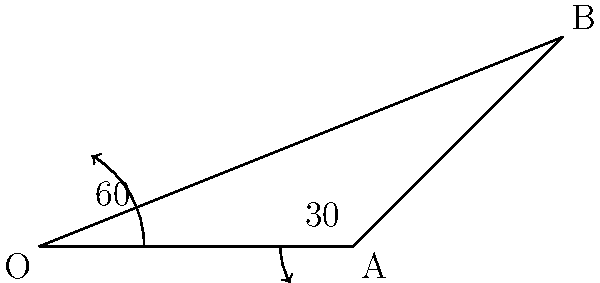In a karate punch, your arm starts at point O and moves to point A (elbow position), then to point B (fist extended). If the angle between OA and AB is 30°, and the angle between OA and the horizontal is 60°, what is the angle between AB and the horizontal? Let's solve this step-by-step:

1. We know that a straight line forms a 180° angle.
2. The arm starts horizontal (0°), then moves up 60°.
3. So, the angle between OA and the horizontal is 60°.
4. The angle between OA and AB is given as 30°.
5. To find the angle between AB and the horizontal, we need to add these angles:
   $60° + 30° = 90°$
6. Therefore, the angle between AB and the horizontal is 90°.

This means that at the end of the punch, your arm will be perpendicular to the ground, forming a right angle with the horizontal.
Answer: 90° 